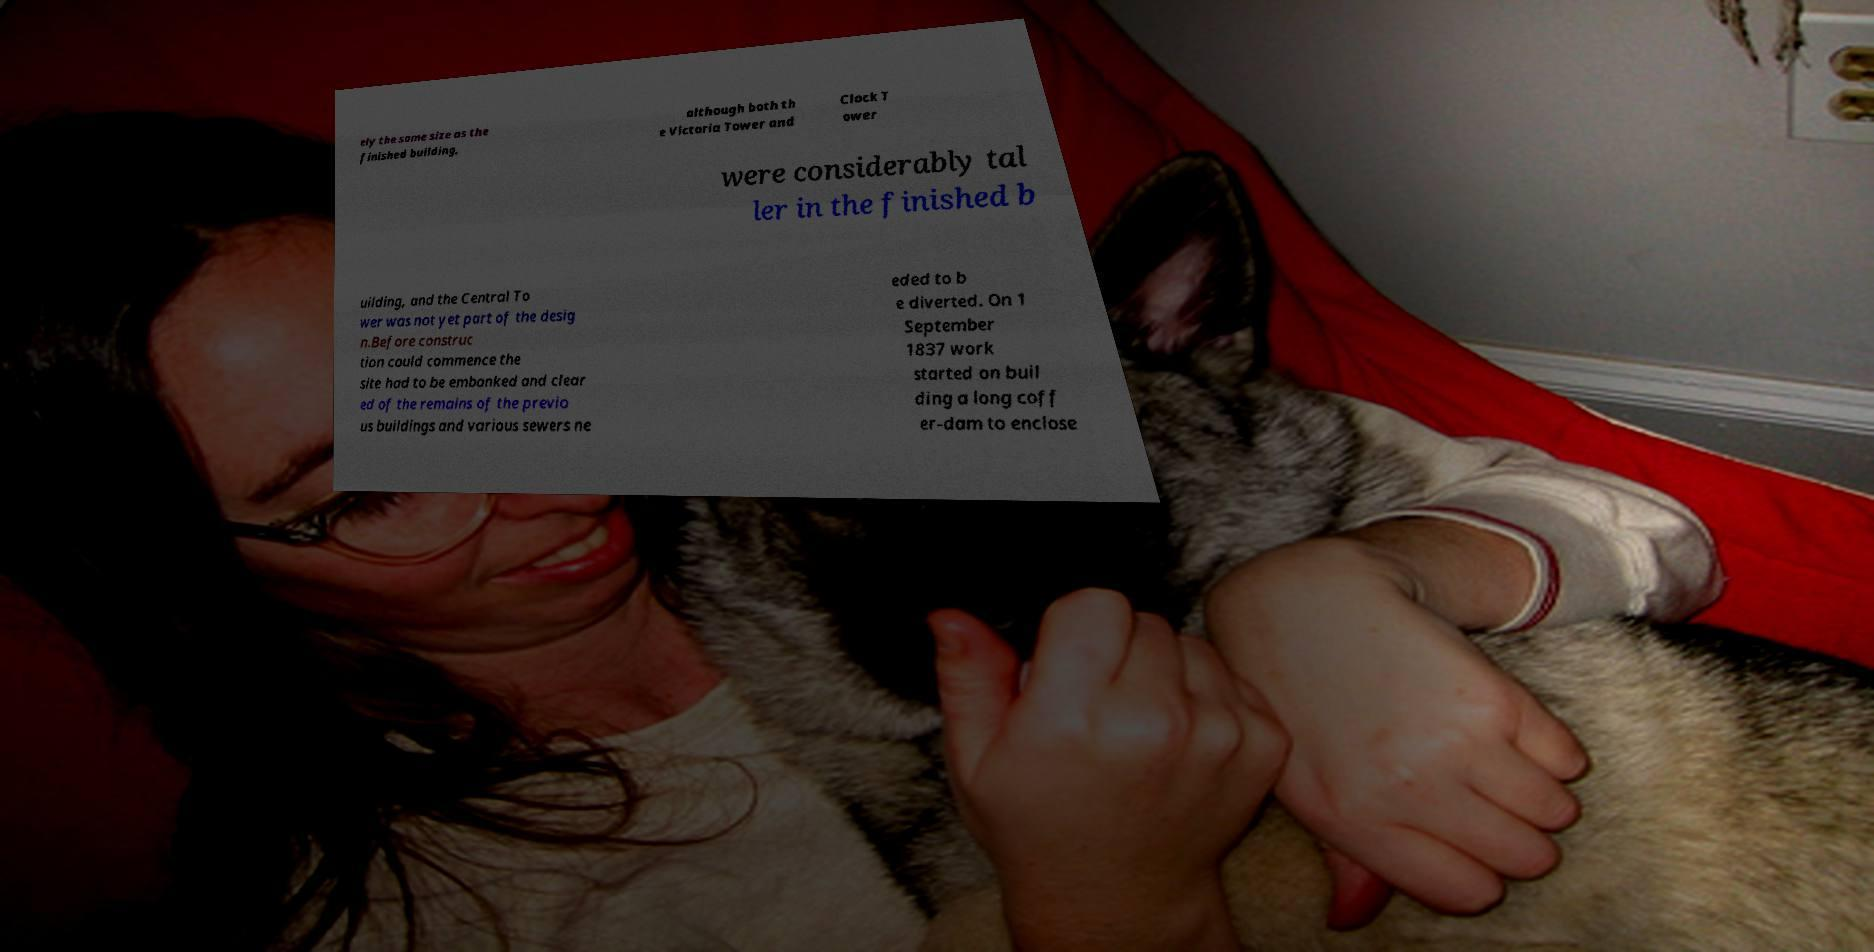For documentation purposes, I need the text within this image transcribed. Could you provide that? ely the same size as the finished building, although both th e Victoria Tower and Clock T ower were considerably tal ler in the finished b uilding, and the Central To wer was not yet part of the desig n.Before construc tion could commence the site had to be embanked and clear ed of the remains of the previo us buildings and various sewers ne eded to b e diverted. On 1 September 1837 work started on buil ding a long coff er-dam to enclose 